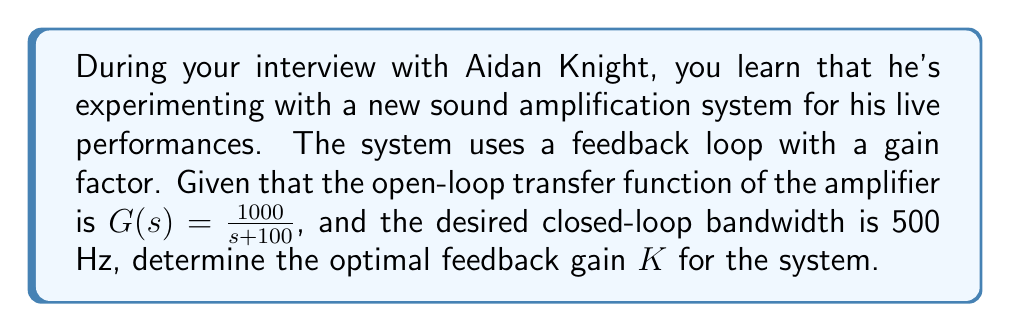Help me with this question. To solve this problem, we'll follow these steps:

1) The closed-loop transfer function of a unity feedback system is given by:

   $$T(s) = \frac{G(s)}{1 + G(s)H(s)}$$

   where $H(s) = K$ in this case (constant gain feedback).

2) Substituting $G(s)$ and $H(s)$:

   $$T(s) = \frac{1000}{s + 100 + 1000K}$$

3) The bandwidth of a first-order system is equal to its cutoff frequency, which is the same as its pole location. For this closed-loop system, the pole is at $s = -(100 + 1000K)$.

4) We want this pole to be at $-2\pi f$, where $f$ is the desired bandwidth in Hz:

   $$100 + 1000K = 2\pi(500)$$

5) Solve for $K$:

   $$1000K = 2\pi(500) - 100$$
   $$K = \frac{2\pi(500) - 100}{1000}$$
   $$K = \frac{\pi - 0.05}{1}$$

6) Calculate the numerical value:

   $$K \approx 3.0916$$

This gain will place the closed-loop pole at the desired location, achieving the 500 Hz bandwidth.
Answer: $K \approx 3.0916$ 